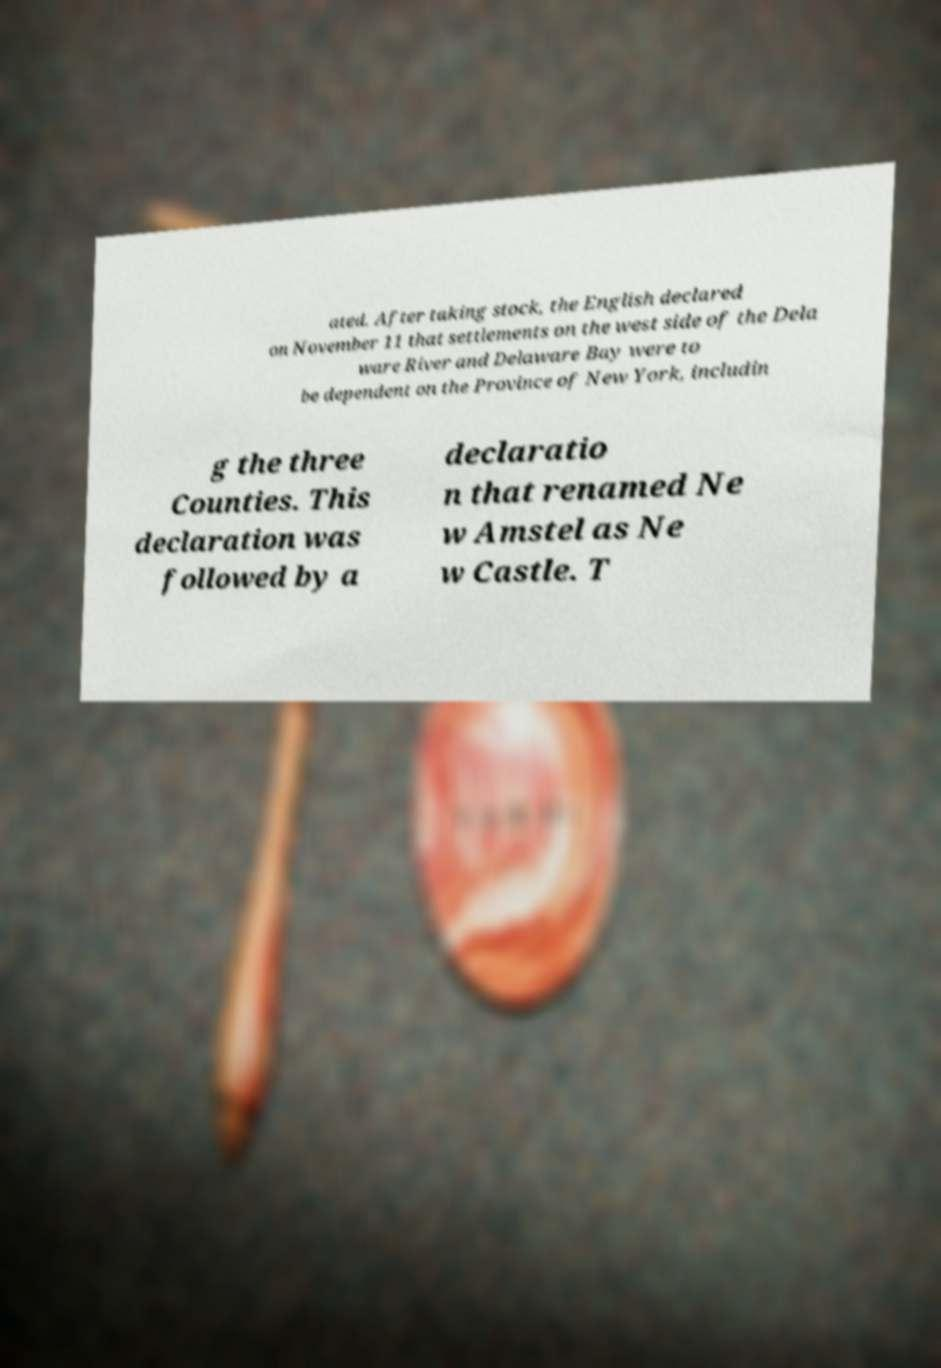Please identify and transcribe the text found in this image. ated. After taking stock, the English declared on November 11 that settlements on the west side of the Dela ware River and Delaware Bay were to be dependent on the Province of New York, includin g the three Counties. This declaration was followed by a declaratio n that renamed Ne w Amstel as Ne w Castle. T 